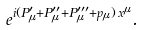<formula> <loc_0><loc_0><loc_500><loc_500>e ^ { i ( P ^ { \prime } _ { \mu } + P ^ { \prime \prime } _ { \mu } + P ^ { \prime \prime \prime } _ { \mu } + p _ { \mu } ) \, x ^ { \mu } } .</formula> 